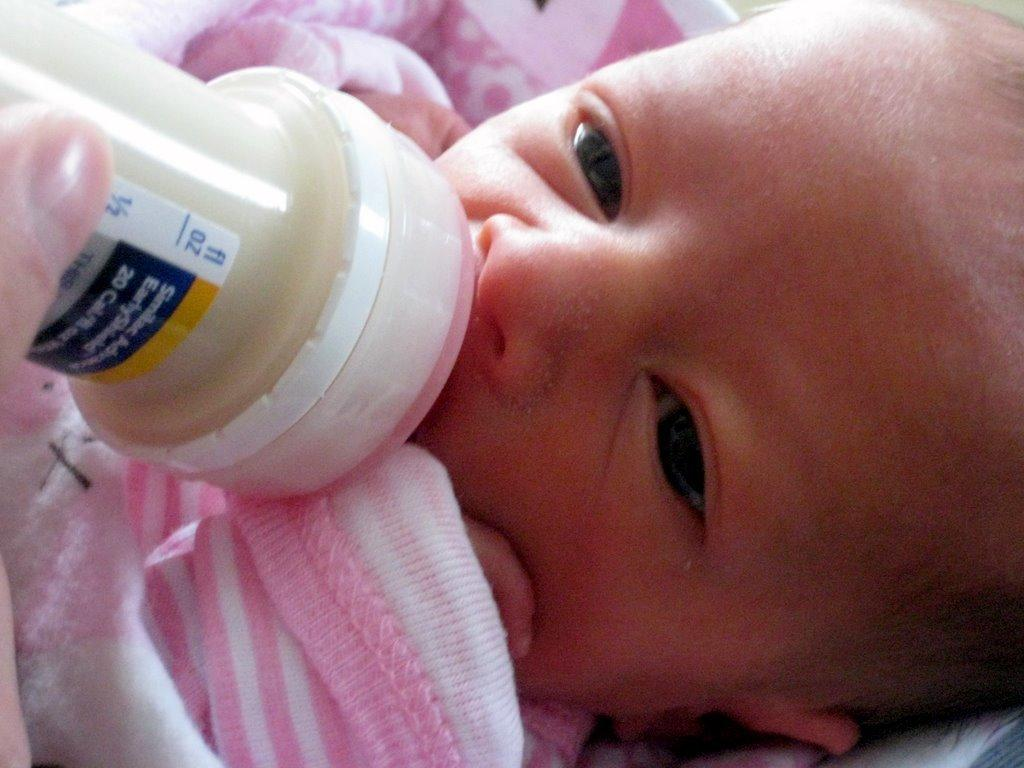What is the main subject of the image? There is a baby in the image. What is the baby's position in the image? The baby is lying down. What is the baby holding in their mouth? The baby is holding a milk bottle in their mouth. What can be seen on the milk bottle? There is a label on the milk bottle. What type of wilderness can be seen in the background of the image? There is no wilderness visible in the image; it features a baby lying down with a milk bottle. How does the baby improve the acoustics of the room in the image? The baby does not improve the acoustics of the room in the image; they are simply lying down with a milk bottle. 